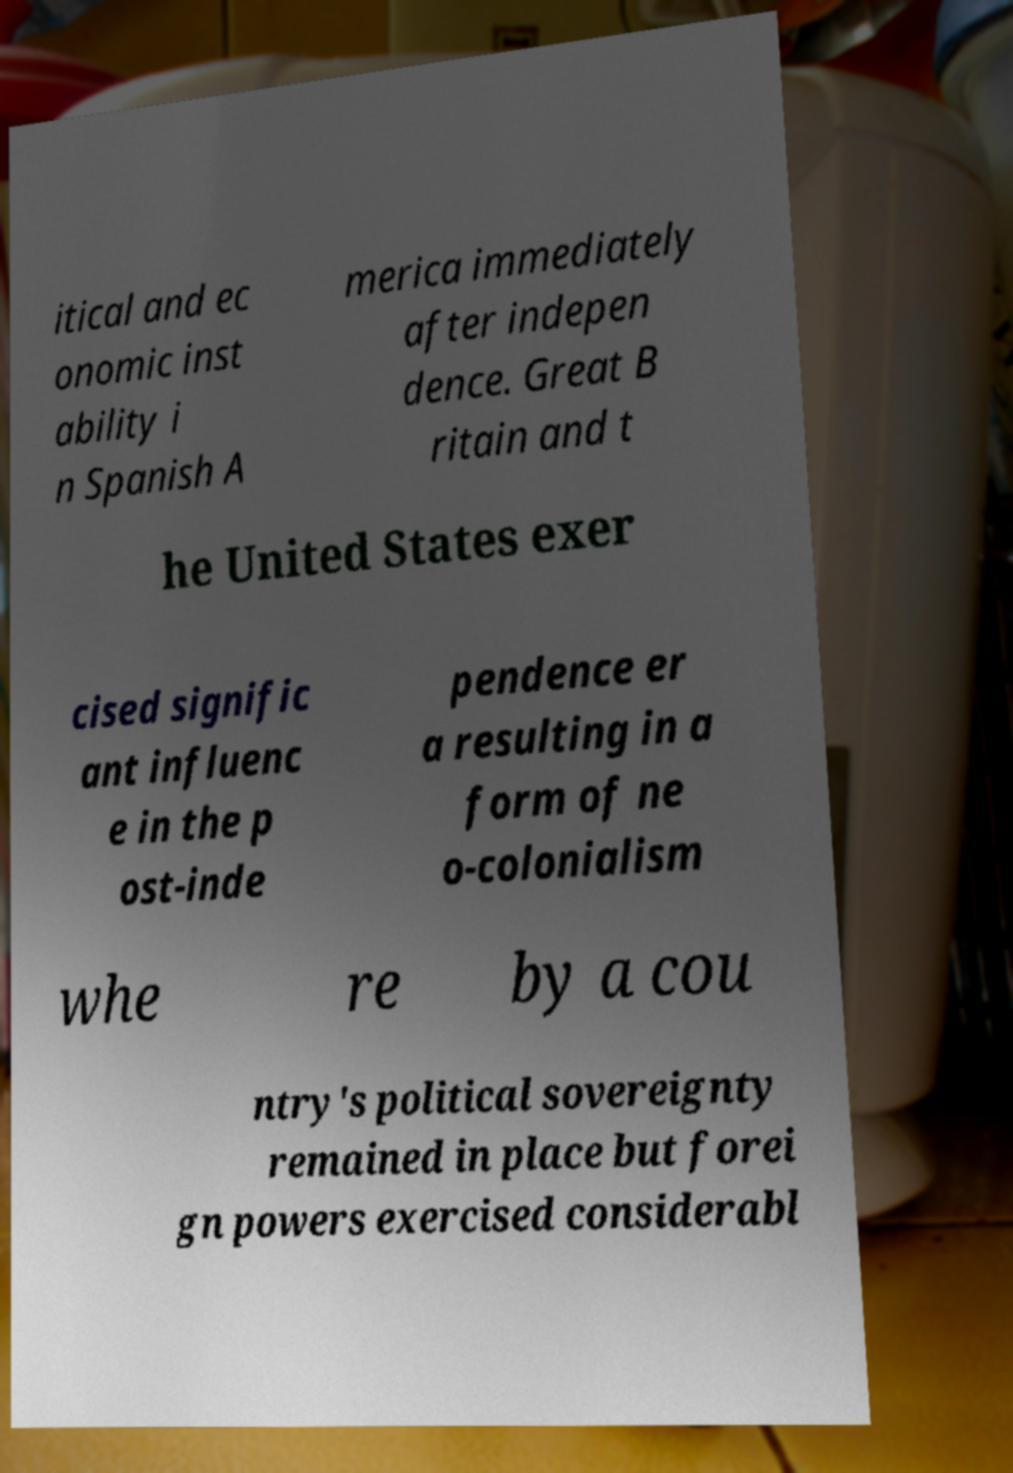Please identify and transcribe the text found in this image. itical and ec onomic inst ability i n Spanish A merica immediately after indepen dence. Great B ritain and t he United States exer cised signific ant influenc e in the p ost-inde pendence er a resulting in a form of ne o-colonialism whe re by a cou ntry's political sovereignty remained in place but forei gn powers exercised considerabl 